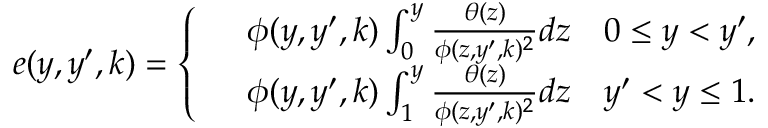<formula> <loc_0><loc_0><loc_500><loc_500>\begin{array} { r } { e ( y , y ^ { \prime } , k ) = \left \{ \begin{array} { r l } & { \phi ( y , y ^ { \prime } , k ) \int _ { 0 } ^ { y } \frac { \theta ( z ) } { \phi ( z , y ^ { \prime } , k ) ^ { 2 } } d z \quad 0 \leq y < y ^ { \prime } , } \\ & { \phi ( y , y ^ { \prime } , k ) \int _ { 1 } ^ { y } \frac { \theta ( z ) } { \phi ( z , y ^ { \prime } , k ) ^ { 2 } } d z \quad y ^ { \prime } < y \leq 1 . } \end{array} } \end{array}</formula> 